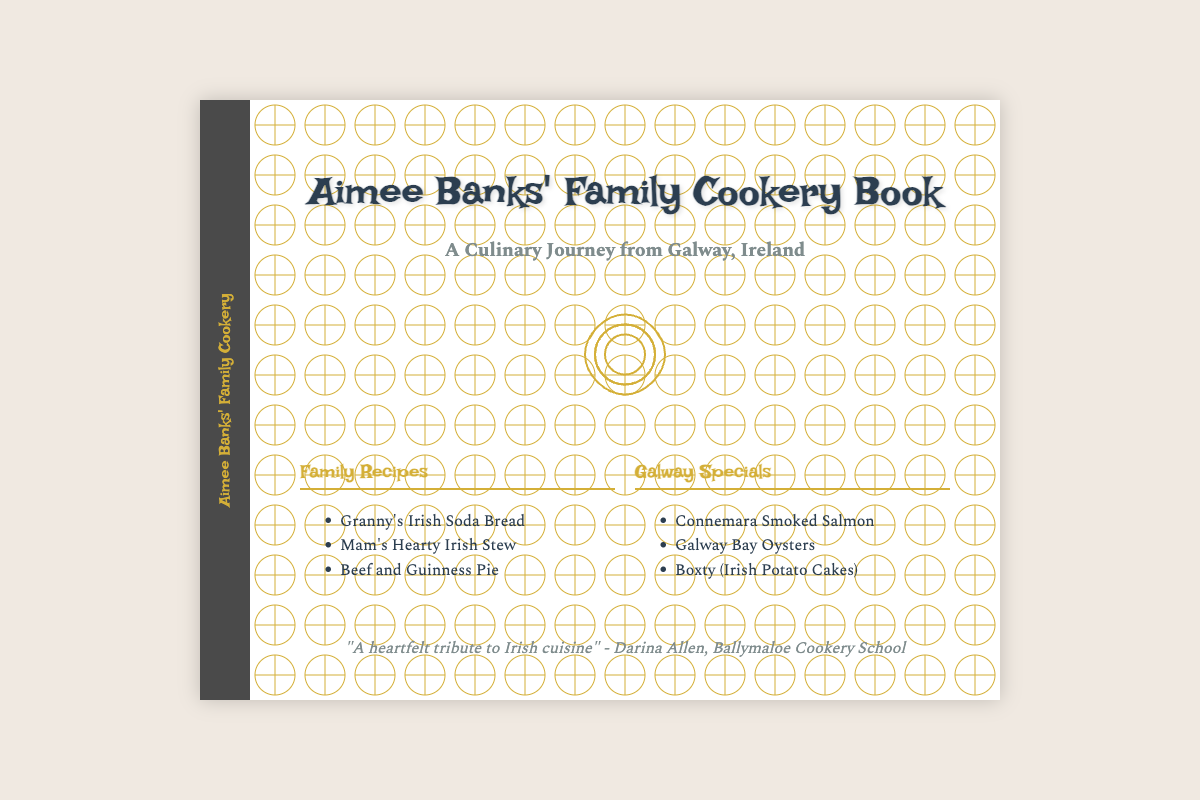What is the title of the book? The title of the book is prominently displayed on the cover of the document.
Answer: Aimee Banks' Family Cookery Book What is the subtitle of the book? The subtitle is located beneath the main title and gives additional context about the book.
Answer: A Culinary Journey from Galway, Ireland Who praised the book in the footer? The footer includes a quote praising the book, along with the name of the person who made the statement.
Answer: Darina Allen What are the names of two family recipes mentioned? The document lists several family recipes under a specific section, providing names for the audience.
Answer: Granny's Irish Soda Bread, Mam's Hearty Irish Stew How many sections are in the book content? The book content area divides the recipes into two distinct sections, which can be counted easily.
Answer: 2 What color is the book spine? The color of the book spine is mentioned, and it is displayed visually.
Answer: Dark grey What type of imagery is used in the book design? Imagery is described in terms of quality and cultural relevance, giving insight into the presentation style used in the book.
Answer: High-quality imagery of Irish culinary culture Which recipe features in the Galway Specials section? The Galway Specials section contains a list of local recipes, where one can be specifically named.
Answer: Connemara Smoked Salmon What style of font is used for the book title? The title's font style is mentioned in the document, reflecting the aesthetic choice for the book.
Answer: Irish Grover 